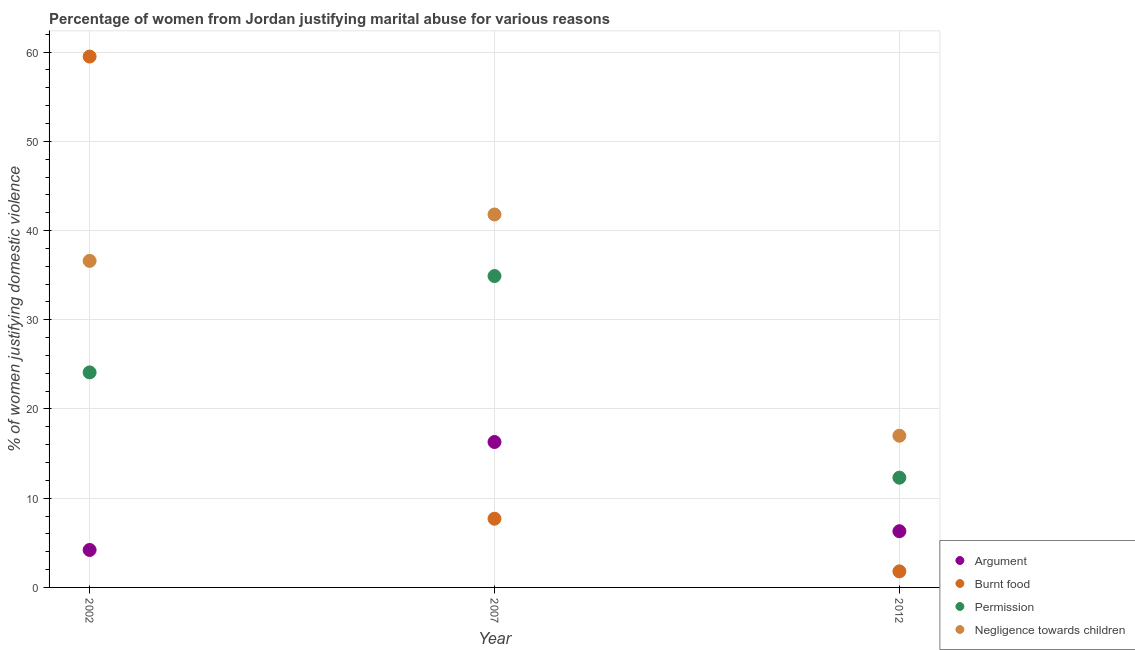How many different coloured dotlines are there?
Make the answer very short. 4. Is the number of dotlines equal to the number of legend labels?
Provide a succinct answer. Yes. What is the percentage of women justifying abuse for burning food in 2012?
Offer a very short reply. 1.8. Across all years, what is the maximum percentage of women justifying abuse for going without permission?
Provide a succinct answer. 34.9. Across all years, what is the minimum percentage of women justifying abuse for burning food?
Provide a succinct answer. 1.8. What is the total percentage of women justifying abuse for going without permission in the graph?
Your answer should be compact. 71.3. What is the difference between the percentage of women justifying abuse for showing negligence towards children in 2007 and the percentage of women justifying abuse for burning food in 2002?
Ensure brevity in your answer.  -17.7. What is the average percentage of women justifying abuse for showing negligence towards children per year?
Provide a succinct answer. 31.8. In the year 2002, what is the difference between the percentage of women justifying abuse for going without permission and percentage of women justifying abuse for burning food?
Provide a short and direct response. -35.4. In how many years, is the percentage of women justifying abuse for burning food greater than 38 %?
Your response must be concise. 1. What is the ratio of the percentage of women justifying abuse in the case of an argument in 2007 to that in 2012?
Offer a very short reply. 2.59. What is the difference between the highest and the second highest percentage of women justifying abuse for burning food?
Offer a terse response. 51.8. What is the difference between the highest and the lowest percentage of women justifying abuse for going without permission?
Your answer should be very brief. 22.6. Is the sum of the percentage of women justifying abuse in the case of an argument in 2002 and 2012 greater than the maximum percentage of women justifying abuse for going without permission across all years?
Make the answer very short. No. Is it the case that in every year, the sum of the percentage of women justifying abuse in the case of an argument and percentage of women justifying abuse for burning food is greater than the percentage of women justifying abuse for going without permission?
Offer a very short reply. No. Does the percentage of women justifying abuse for showing negligence towards children monotonically increase over the years?
Offer a very short reply. No. Is the percentage of women justifying abuse for showing negligence towards children strictly greater than the percentage of women justifying abuse for going without permission over the years?
Your response must be concise. Yes. Is the percentage of women justifying abuse for going without permission strictly less than the percentage of women justifying abuse for burning food over the years?
Give a very brief answer. No. Does the graph contain any zero values?
Make the answer very short. No. Where does the legend appear in the graph?
Provide a short and direct response. Bottom right. How are the legend labels stacked?
Your response must be concise. Vertical. What is the title of the graph?
Your response must be concise. Percentage of women from Jordan justifying marital abuse for various reasons. Does "Structural Policies" appear as one of the legend labels in the graph?
Keep it short and to the point. No. What is the label or title of the Y-axis?
Provide a short and direct response. % of women justifying domestic violence. What is the % of women justifying domestic violence in Argument in 2002?
Keep it short and to the point. 4.2. What is the % of women justifying domestic violence in Burnt food in 2002?
Your answer should be very brief. 59.5. What is the % of women justifying domestic violence of Permission in 2002?
Offer a terse response. 24.1. What is the % of women justifying domestic violence in Negligence towards children in 2002?
Provide a succinct answer. 36.6. What is the % of women justifying domestic violence of Burnt food in 2007?
Your answer should be compact. 7.7. What is the % of women justifying domestic violence in Permission in 2007?
Give a very brief answer. 34.9. What is the % of women justifying domestic violence of Negligence towards children in 2007?
Your answer should be very brief. 41.8. What is the % of women justifying domestic violence in Argument in 2012?
Your response must be concise. 6.3. What is the % of women justifying domestic violence in Negligence towards children in 2012?
Keep it short and to the point. 17. Across all years, what is the maximum % of women justifying domestic violence in Burnt food?
Ensure brevity in your answer.  59.5. Across all years, what is the maximum % of women justifying domestic violence of Permission?
Your response must be concise. 34.9. Across all years, what is the maximum % of women justifying domestic violence in Negligence towards children?
Ensure brevity in your answer.  41.8. Across all years, what is the minimum % of women justifying domestic violence in Argument?
Ensure brevity in your answer.  4.2. Across all years, what is the minimum % of women justifying domestic violence in Burnt food?
Your answer should be very brief. 1.8. Across all years, what is the minimum % of women justifying domestic violence of Negligence towards children?
Keep it short and to the point. 17. What is the total % of women justifying domestic violence in Argument in the graph?
Keep it short and to the point. 26.8. What is the total % of women justifying domestic violence of Burnt food in the graph?
Provide a short and direct response. 69. What is the total % of women justifying domestic violence of Permission in the graph?
Ensure brevity in your answer.  71.3. What is the total % of women justifying domestic violence of Negligence towards children in the graph?
Offer a terse response. 95.4. What is the difference between the % of women justifying domestic violence of Argument in 2002 and that in 2007?
Ensure brevity in your answer.  -12.1. What is the difference between the % of women justifying domestic violence in Burnt food in 2002 and that in 2007?
Your response must be concise. 51.8. What is the difference between the % of women justifying domestic violence of Permission in 2002 and that in 2007?
Offer a terse response. -10.8. What is the difference between the % of women justifying domestic violence of Negligence towards children in 2002 and that in 2007?
Offer a terse response. -5.2. What is the difference between the % of women justifying domestic violence in Burnt food in 2002 and that in 2012?
Provide a succinct answer. 57.7. What is the difference between the % of women justifying domestic violence in Negligence towards children in 2002 and that in 2012?
Offer a terse response. 19.6. What is the difference between the % of women justifying domestic violence of Argument in 2007 and that in 2012?
Offer a terse response. 10. What is the difference between the % of women justifying domestic violence in Permission in 2007 and that in 2012?
Keep it short and to the point. 22.6. What is the difference between the % of women justifying domestic violence in Negligence towards children in 2007 and that in 2012?
Keep it short and to the point. 24.8. What is the difference between the % of women justifying domestic violence in Argument in 2002 and the % of women justifying domestic violence in Permission in 2007?
Give a very brief answer. -30.7. What is the difference between the % of women justifying domestic violence in Argument in 2002 and the % of women justifying domestic violence in Negligence towards children in 2007?
Your answer should be compact. -37.6. What is the difference between the % of women justifying domestic violence of Burnt food in 2002 and the % of women justifying domestic violence of Permission in 2007?
Offer a terse response. 24.6. What is the difference between the % of women justifying domestic violence in Burnt food in 2002 and the % of women justifying domestic violence in Negligence towards children in 2007?
Your answer should be very brief. 17.7. What is the difference between the % of women justifying domestic violence in Permission in 2002 and the % of women justifying domestic violence in Negligence towards children in 2007?
Provide a succinct answer. -17.7. What is the difference between the % of women justifying domestic violence in Argument in 2002 and the % of women justifying domestic violence in Burnt food in 2012?
Your answer should be very brief. 2.4. What is the difference between the % of women justifying domestic violence of Argument in 2002 and the % of women justifying domestic violence of Permission in 2012?
Make the answer very short. -8.1. What is the difference between the % of women justifying domestic violence in Burnt food in 2002 and the % of women justifying domestic violence in Permission in 2012?
Your answer should be very brief. 47.2. What is the difference between the % of women justifying domestic violence in Burnt food in 2002 and the % of women justifying domestic violence in Negligence towards children in 2012?
Your answer should be very brief. 42.5. What is the difference between the % of women justifying domestic violence of Permission in 2002 and the % of women justifying domestic violence of Negligence towards children in 2012?
Make the answer very short. 7.1. What is the difference between the % of women justifying domestic violence of Argument in 2007 and the % of women justifying domestic violence of Burnt food in 2012?
Make the answer very short. 14.5. What is the difference between the % of women justifying domestic violence in Argument in 2007 and the % of women justifying domestic violence in Permission in 2012?
Ensure brevity in your answer.  4. What is the difference between the % of women justifying domestic violence of Argument in 2007 and the % of women justifying domestic violence of Negligence towards children in 2012?
Your answer should be very brief. -0.7. What is the difference between the % of women justifying domestic violence of Burnt food in 2007 and the % of women justifying domestic violence of Permission in 2012?
Offer a terse response. -4.6. What is the difference between the % of women justifying domestic violence in Burnt food in 2007 and the % of women justifying domestic violence in Negligence towards children in 2012?
Give a very brief answer. -9.3. What is the difference between the % of women justifying domestic violence in Permission in 2007 and the % of women justifying domestic violence in Negligence towards children in 2012?
Offer a terse response. 17.9. What is the average % of women justifying domestic violence of Argument per year?
Keep it short and to the point. 8.93. What is the average % of women justifying domestic violence of Burnt food per year?
Your response must be concise. 23. What is the average % of women justifying domestic violence in Permission per year?
Keep it short and to the point. 23.77. What is the average % of women justifying domestic violence in Negligence towards children per year?
Offer a very short reply. 31.8. In the year 2002, what is the difference between the % of women justifying domestic violence in Argument and % of women justifying domestic violence in Burnt food?
Ensure brevity in your answer.  -55.3. In the year 2002, what is the difference between the % of women justifying domestic violence of Argument and % of women justifying domestic violence of Permission?
Give a very brief answer. -19.9. In the year 2002, what is the difference between the % of women justifying domestic violence in Argument and % of women justifying domestic violence in Negligence towards children?
Make the answer very short. -32.4. In the year 2002, what is the difference between the % of women justifying domestic violence of Burnt food and % of women justifying domestic violence of Permission?
Make the answer very short. 35.4. In the year 2002, what is the difference between the % of women justifying domestic violence of Burnt food and % of women justifying domestic violence of Negligence towards children?
Provide a short and direct response. 22.9. In the year 2002, what is the difference between the % of women justifying domestic violence of Permission and % of women justifying domestic violence of Negligence towards children?
Ensure brevity in your answer.  -12.5. In the year 2007, what is the difference between the % of women justifying domestic violence of Argument and % of women justifying domestic violence of Burnt food?
Keep it short and to the point. 8.6. In the year 2007, what is the difference between the % of women justifying domestic violence of Argument and % of women justifying domestic violence of Permission?
Your response must be concise. -18.6. In the year 2007, what is the difference between the % of women justifying domestic violence of Argument and % of women justifying domestic violence of Negligence towards children?
Offer a terse response. -25.5. In the year 2007, what is the difference between the % of women justifying domestic violence of Burnt food and % of women justifying domestic violence of Permission?
Your answer should be very brief. -27.2. In the year 2007, what is the difference between the % of women justifying domestic violence in Burnt food and % of women justifying domestic violence in Negligence towards children?
Provide a short and direct response. -34.1. In the year 2007, what is the difference between the % of women justifying domestic violence in Permission and % of women justifying domestic violence in Negligence towards children?
Make the answer very short. -6.9. In the year 2012, what is the difference between the % of women justifying domestic violence of Argument and % of women justifying domestic violence of Negligence towards children?
Ensure brevity in your answer.  -10.7. In the year 2012, what is the difference between the % of women justifying domestic violence of Burnt food and % of women justifying domestic violence of Negligence towards children?
Your answer should be compact. -15.2. In the year 2012, what is the difference between the % of women justifying domestic violence of Permission and % of women justifying domestic violence of Negligence towards children?
Provide a short and direct response. -4.7. What is the ratio of the % of women justifying domestic violence of Argument in 2002 to that in 2007?
Your response must be concise. 0.26. What is the ratio of the % of women justifying domestic violence of Burnt food in 2002 to that in 2007?
Offer a very short reply. 7.73. What is the ratio of the % of women justifying domestic violence of Permission in 2002 to that in 2007?
Your response must be concise. 0.69. What is the ratio of the % of women justifying domestic violence of Negligence towards children in 2002 to that in 2007?
Your response must be concise. 0.88. What is the ratio of the % of women justifying domestic violence of Argument in 2002 to that in 2012?
Your answer should be compact. 0.67. What is the ratio of the % of women justifying domestic violence in Burnt food in 2002 to that in 2012?
Make the answer very short. 33.06. What is the ratio of the % of women justifying domestic violence of Permission in 2002 to that in 2012?
Give a very brief answer. 1.96. What is the ratio of the % of women justifying domestic violence of Negligence towards children in 2002 to that in 2012?
Provide a short and direct response. 2.15. What is the ratio of the % of women justifying domestic violence in Argument in 2007 to that in 2012?
Ensure brevity in your answer.  2.59. What is the ratio of the % of women justifying domestic violence of Burnt food in 2007 to that in 2012?
Offer a very short reply. 4.28. What is the ratio of the % of women justifying domestic violence in Permission in 2007 to that in 2012?
Offer a terse response. 2.84. What is the ratio of the % of women justifying domestic violence of Negligence towards children in 2007 to that in 2012?
Your answer should be very brief. 2.46. What is the difference between the highest and the second highest % of women justifying domestic violence of Argument?
Ensure brevity in your answer.  10. What is the difference between the highest and the second highest % of women justifying domestic violence of Burnt food?
Keep it short and to the point. 51.8. What is the difference between the highest and the second highest % of women justifying domestic violence in Permission?
Provide a short and direct response. 10.8. What is the difference between the highest and the lowest % of women justifying domestic violence in Burnt food?
Ensure brevity in your answer.  57.7. What is the difference between the highest and the lowest % of women justifying domestic violence of Permission?
Make the answer very short. 22.6. What is the difference between the highest and the lowest % of women justifying domestic violence in Negligence towards children?
Your response must be concise. 24.8. 